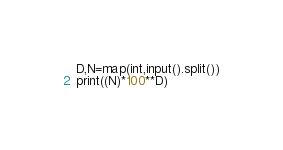Convert code to text. <code><loc_0><loc_0><loc_500><loc_500><_Python_>D,N=map(int,input().split())
print((N)*100**D)</code> 